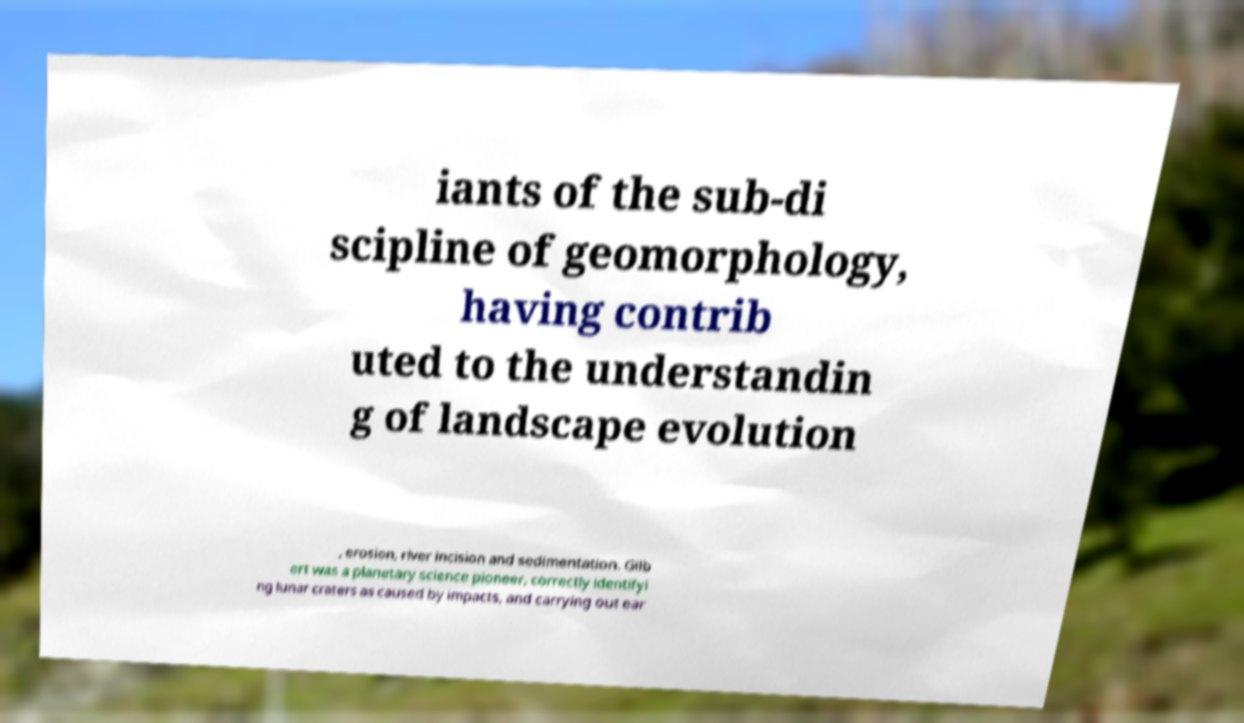Can you read and provide the text displayed in the image?This photo seems to have some interesting text. Can you extract and type it out for me? iants of the sub-di scipline of geomorphology, having contrib uted to the understandin g of landscape evolution , erosion, river incision and sedimentation. Gilb ert was a planetary science pioneer, correctly identifyi ng lunar craters as caused by impacts, and carrying out ear 